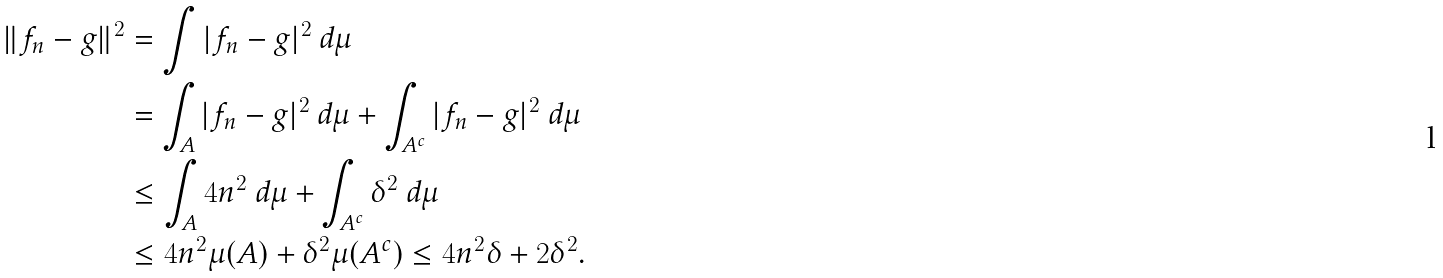<formula> <loc_0><loc_0><loc_500><loc_500>\| f _ { n } - g \| ^ { 2 } & = \int | f _ { n } - g | ^ { 2 } \ d \mu \\ & = \int _ { A } | f _ { n } - g | ^ { 2 } \ d \mu + \int _ { A ^ { c } } | f _ { n } - g | ^ { 2 } \ d \mu \\ & \leq \int _ { A } 4 n ^ { 2 } \ d \mu + \int _ { A ^ { c } } \delta ^ { 2 } \ d \mu \\ & \leq 4 n ^ { 2 } \mu ( A ) + \delta ^ { 2 } \mu ( A ^ { c } ) \leq 4 n ^ { 2 } \delta + 2 \delta ^ { 2 } .</formula> 